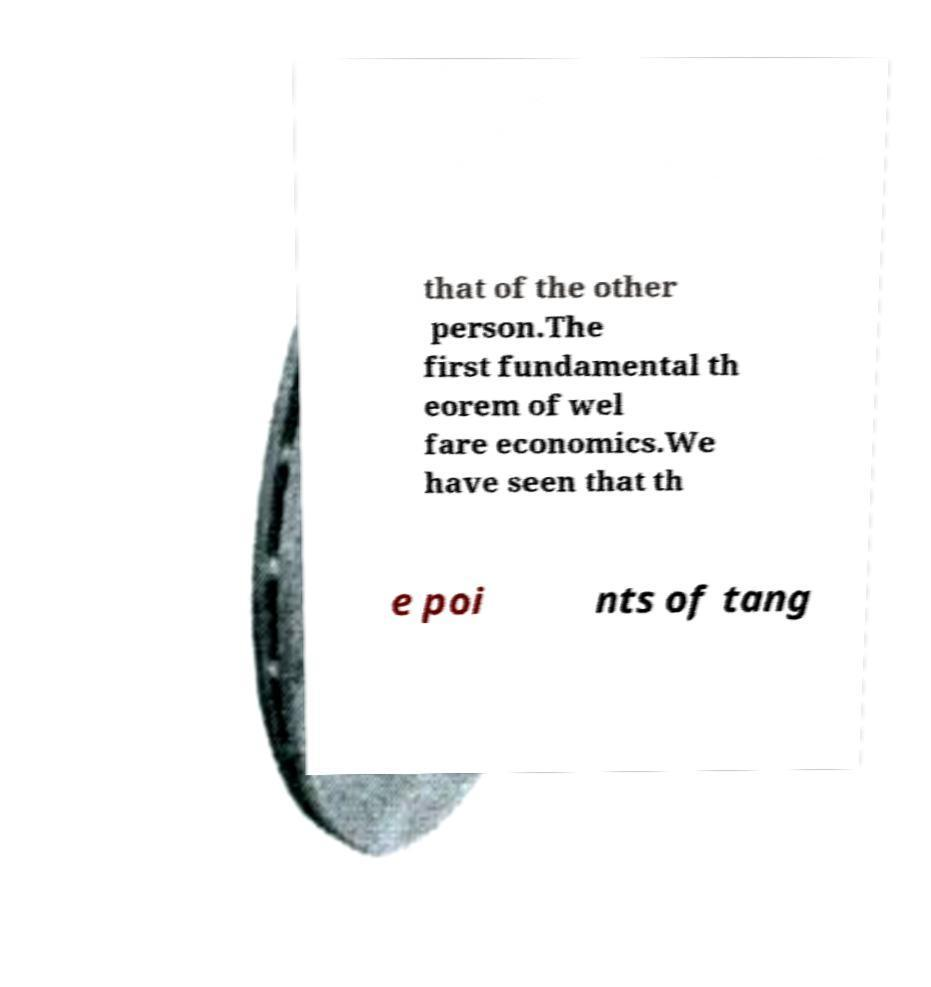There's text embedded in this image that I need extracted. Can you transcribe it verbatim? that of the other person.The first fundamental th eorem of wel fare economics.We have seen that th e poi nts of tang 